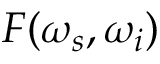<formula> <loc_0><loc_0><loc_500><loc_500>F ( \omega _ { s } , \omega _ { i } )</formula> 